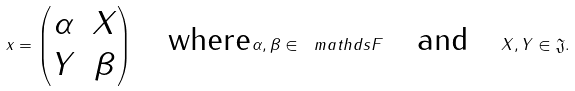<formula> <loc_0><loc_0><loc_500><loc_500>x = \begin{pmatrix} \alpha & X \\ Y & \beta \end{pmatrix} \quad \text {where} \alpha , \beta \in \ m a t h d s { F } \quad \text {and} \quad X , Y \in \mathfrak { J } .</formula> 